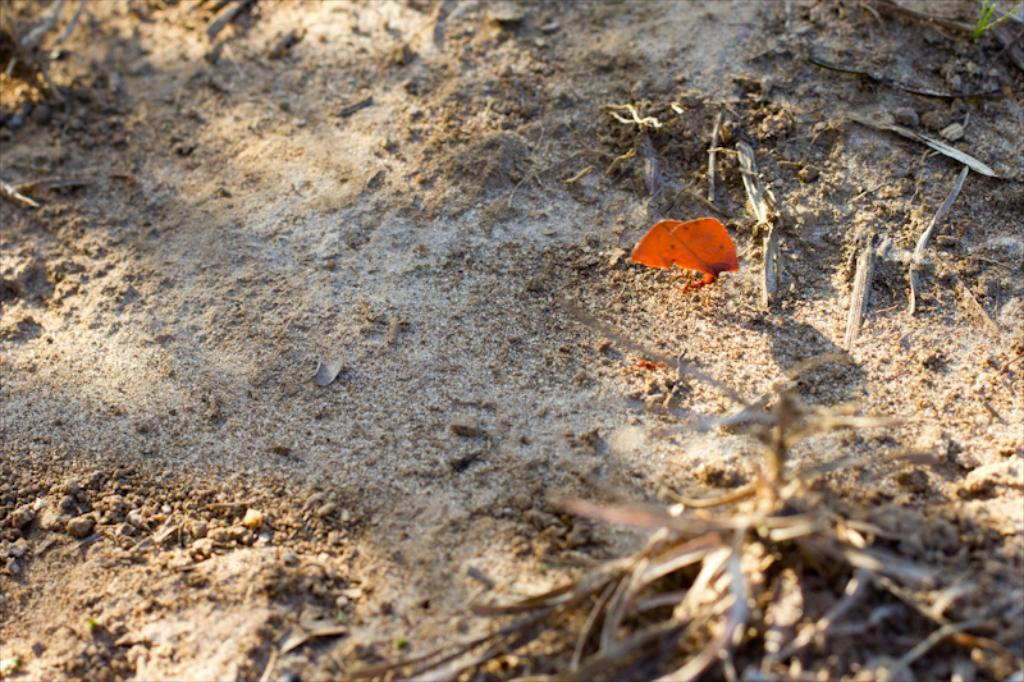What is the main object in the center of the image? There is an object in the center of the image, and it is orange in color. What else can be seen in the image besides the orange object? There are sticks and small stones visible in the image, as well as a few other objects. What color are the sticks in the image? The provided facts do not mention the color of the sticks. How many other objects are present in the image? The provided facts mention that there are a few other objects in the image, but the exact number is not specified. What type of bell can be heard ringing in the image? There is no bell present in the image, and therefore no sound can be heard. 